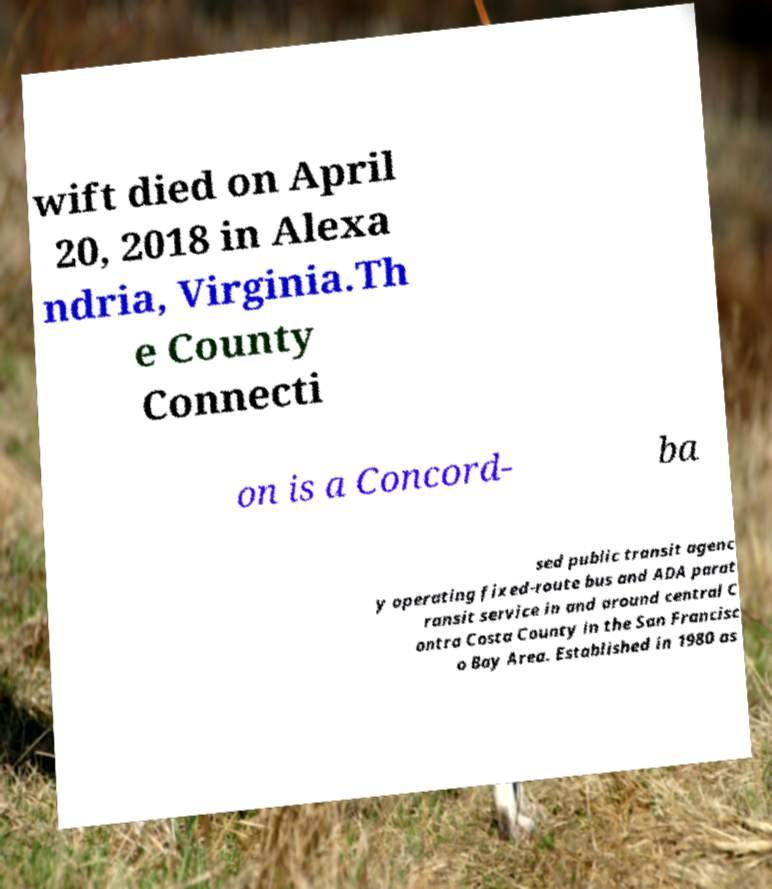Can you read and provide the text displayed in the image?This photo seems to have some interesting text. Can you extract and type it out for me? wift died on April 20, 2018 in Alexa ndria, Virginia.Th e County Connecti on is a Concord- ba sed public transit agenc y operating fixed-route bus and ADA parat ransit service in and around central C ontra Costa County in the San Francisc o Bay Area. Established in 1980 as 